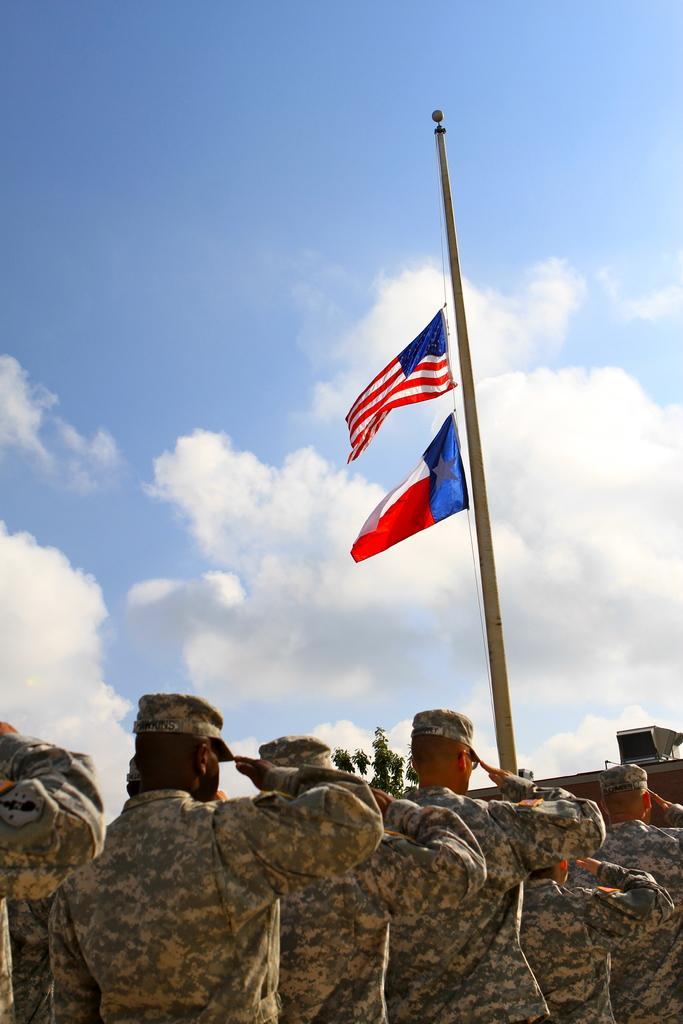Describe this image in one or two sentences. In this image I can see at the bottom a group of men are in army dress are saluting to the flags in the middle. At the top there is the cloudy sky. 